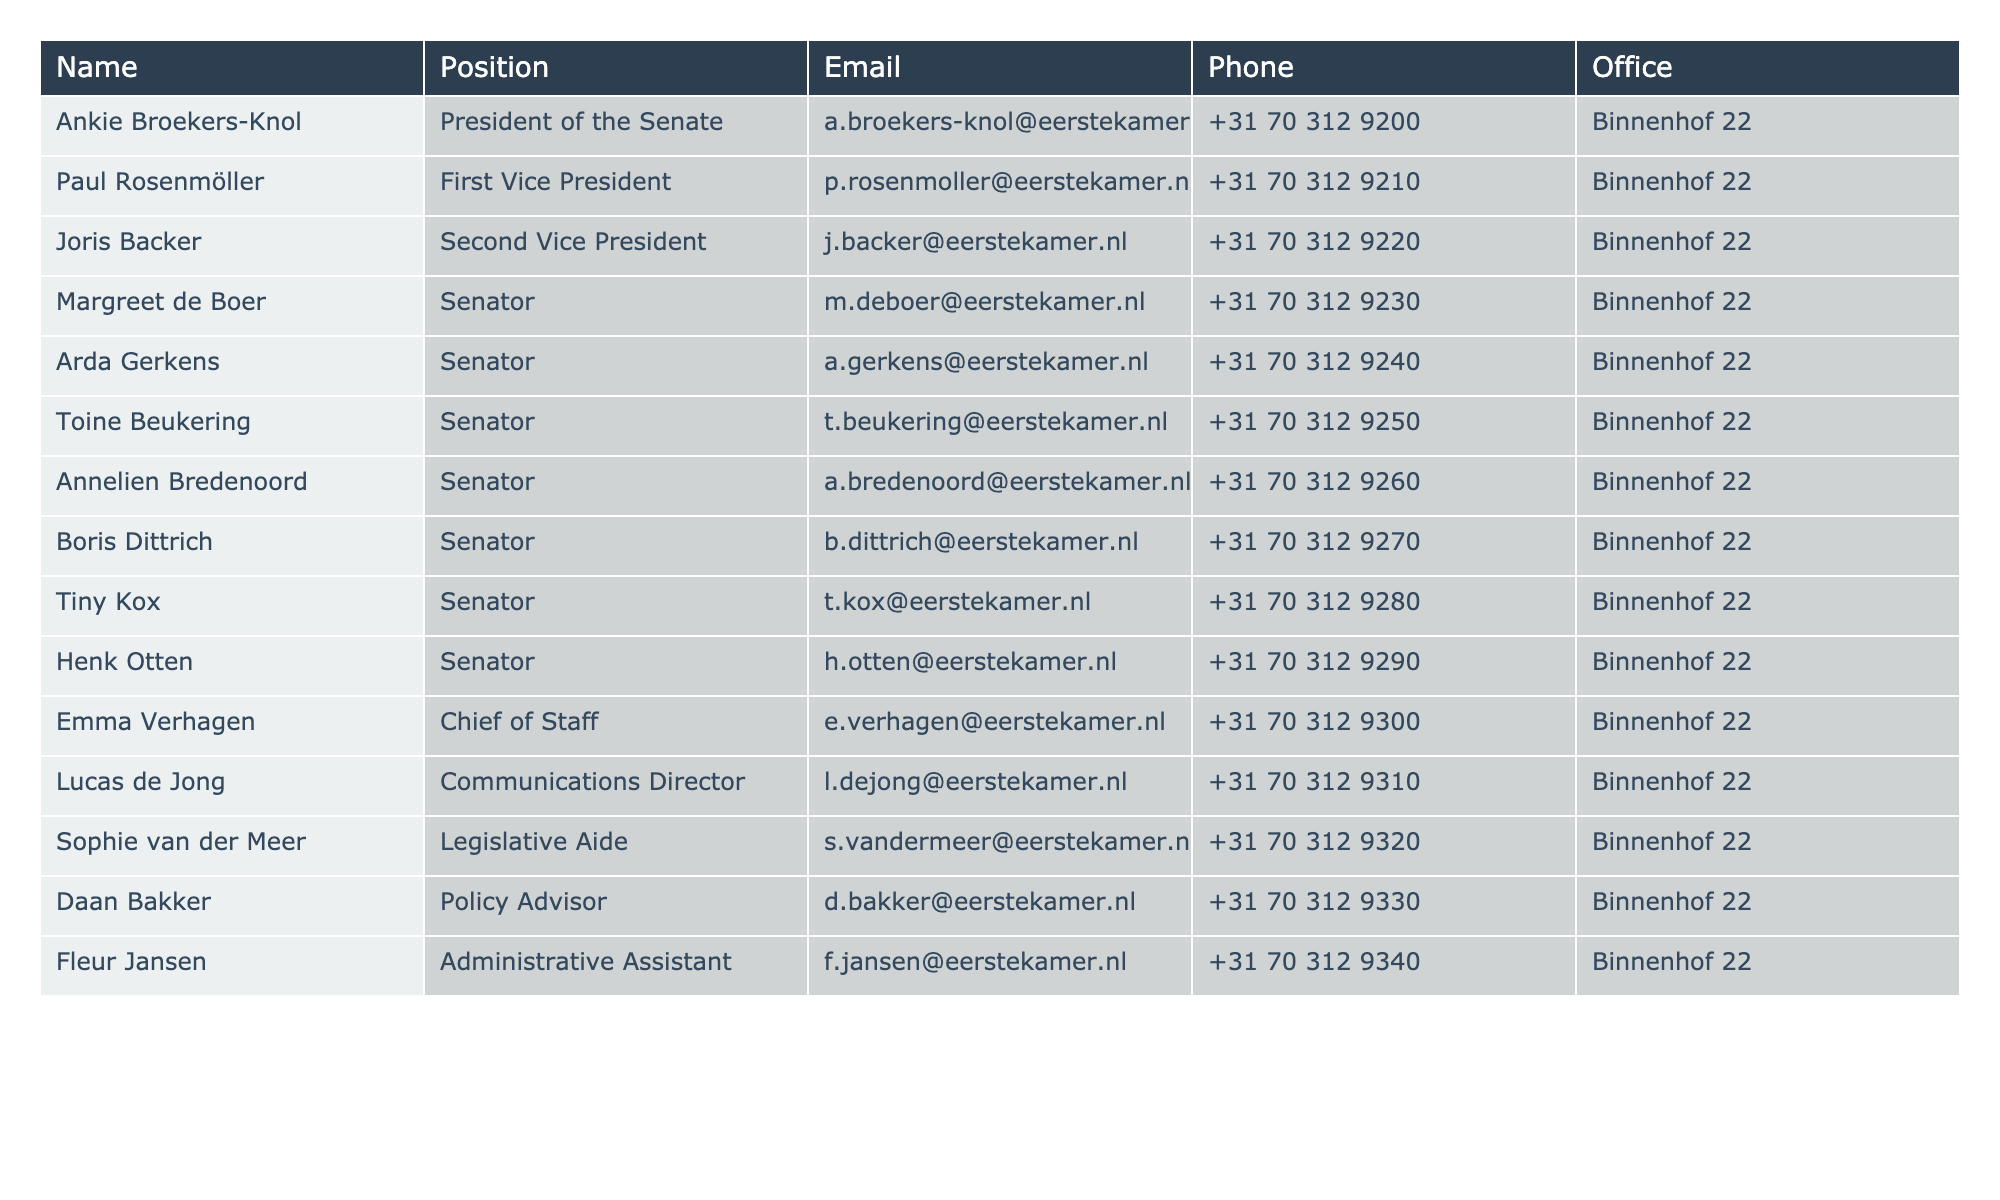What's the email address of the President of the Senate? The President of the Senate is Ankie Broekers-Knol, and her email address is shown in the table. I can directly refer to the row where her name appears to find the email address.
Answer: a.broekers-knol@eerstekamer.nl Who is the Chief of Staff, and what is their phone number? The Chief of Staff is Emma Verhagen. To find her phone number, I look at the same row under the Phone column.
Answer: +31 70 312 9300 How many Senators listed are there in the table? The table contains a specific position designation of "Senator." By counting the rows with this designation, I can determine the total number of Senators listed.
Answer: 8 Is there a Communications Director among the current staff? I can verify this by checking the Position column for the title "Communications Director." If it is present, then the answer is yes; otherwise, it is no.
Answer: Yes What is the phone number of the Second Vice President? The Second Vice President is Joris Backer. To get the phone number, I locate his entry in the table and refer to the Phone column corresponding to his name.
Answer: +31 70 312 9220 What is the total number of staff members listed in the table? I count all unique positions listed in the table and see that there are 3 distinct categories: Senators, Chief of Staff, and other staff positions. I sum up these positions to get the total count of staff members.
Answer: 12 Do all Senators share the same office location? Based on the Office column, I can check if all Senators listed have the same address. If they all have "Binnenhof 22," it confirms that they share the same office location.
Answer: Yes Who has the phone number that ends with "9310"? I need to look for the row in the Phone column that ends with "9310" and identify the corresponding Name. This involves scanning through the Phone numbers for the match.
Answer: Lucas de Jong What position does Boris Dittrich hold, and what is his email address? By searching for Boris Dittrich in the table, I find the corresponding position and email address in the relevant columns under his name.
Answer: Senator, b.dittrich@eerstekamer.nl 